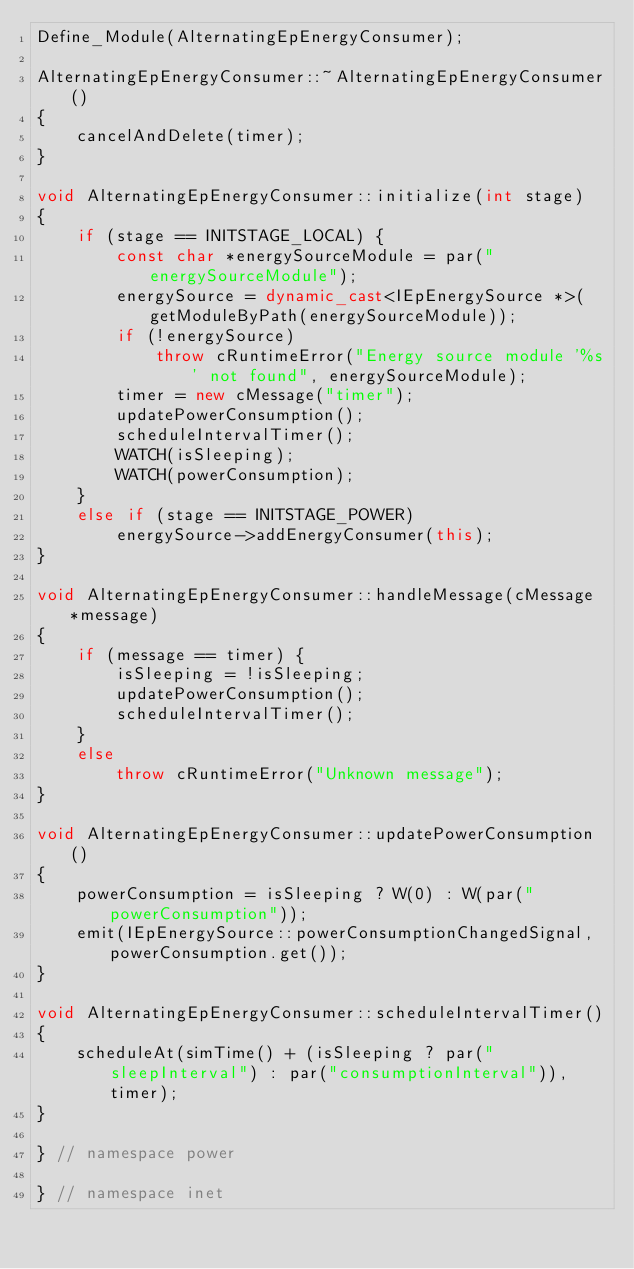Convert code to text. <code><loc_0><loc_0><loc_500><loc_500><_C++_>Define_Module(AlternatingEpEnergyConsumer);

AlternatingEpEnergyConsumer::~AlternatingEpEnergyConsumer()
{
    cancelAndDelete(timer);
}

void AlternatingEpEnergyConsumer::initialize(int stage)
{
    if (stage == INITSTAGE_LOCAL) {
        const char *energySourceModule = par("energySourceModule");
        energySource = dynamic_cast<IEpEnergySource *>(getModuleByPath(energySourceModule));
        if (!energySource)
            throw cRuntimeError("Energy source module '%s' not found", energySourceModule);
        timer = new cMessage("timer");
        updatePowerConsumption();
        scheduleIntervalTimer();
        WATCH(isSleeping);
        WATCH(powerConsumption);
    }
    else if (stage == INITSTAGE_POWER)
        energySource->addEnergyConsumer(this);
}

void AlternatingEpEnergyConsumer::handleMessage(cMessage *message)
{
    if (message == timer) {
        isSleeping = !isSleeping;
        updatePowerConsumption();
        scheduleIntervalTimer();
    }
    else
        throw cRuntimeError("Unknown message");
}

void AlternatingEpEnergyConsumer::updatePowerConsumption()
{
    powerConsumption = isSleeping ? W(0) : W(par("powerConsumption"));
    emit(IEpEnergySource::powerConsumptionChangedSignal, powerConsumption.get());
}

void AlternatingEpEnergyConsumer::scheduleIntervalTimer()
{
    scheduleAt(simTime() + (isSleeping ? par("sleepInterval") : par("consumptionInterval")), timer);
}

} // namespace power

} // namespace inet

</code> 